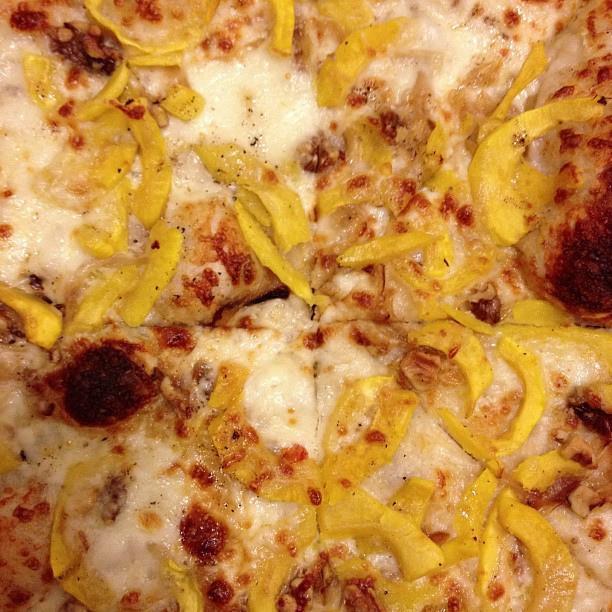How many visible train cars have flat roofs?
Give a very brief answer. 0. 